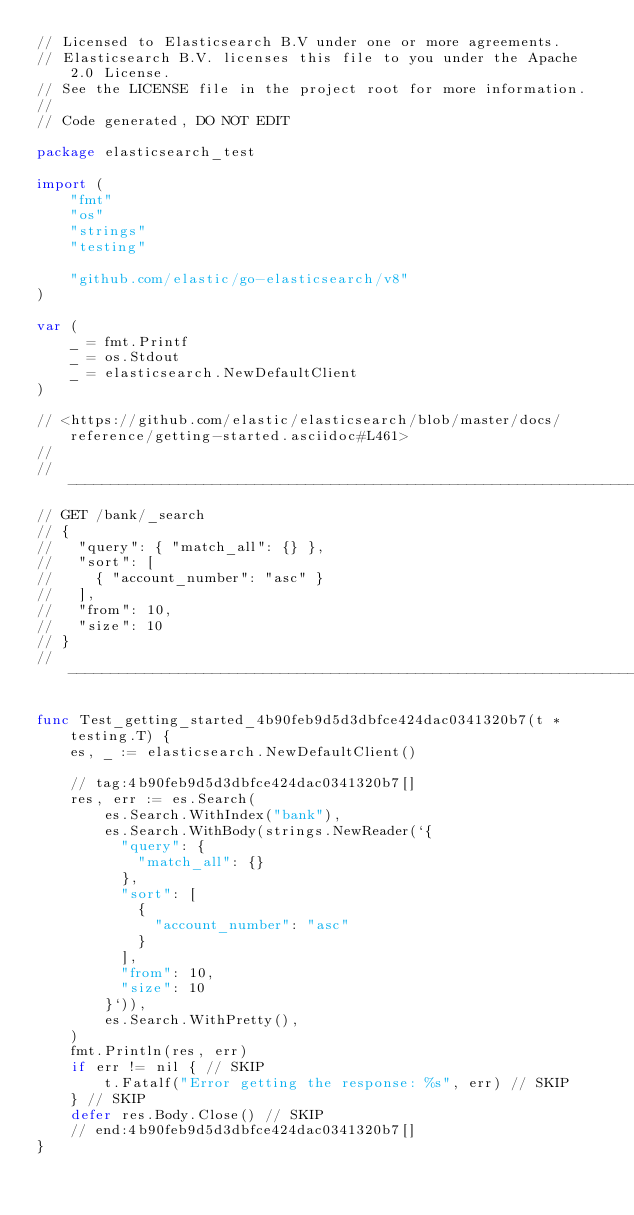<code> <loc_0><loc_0><loc_500><loc_500><_Go_>// Licensed to Elasticsearch B.V under one or more agreements.
// Elasticsearch B.V. licenses this file to you under the Apache 2.0 License.
// See the LICENSE file in the project root for more information.
//
// Code generated, DO NOT EDIT

package elasticsearch_test

import (
	"fmt"
	"os"
	"strings"
	"testing"

	"github.com/elastic/go-elasticsearch/v8"
)

var (
	_ = fmt.Printf
	_ = os.Stdout
	_ = elasticsearch.NewDefaultClient
)

// <https://github.com/elastic/elasticsearch/blob/master/docs/reference/getting-started.asciidoc#L461>
//
// --------------------------------------------------------------------------------
// GET /bank/_search
// {
//   "query": { "match_all": {} },
//   "sort": [
//     { "account_number": "asc" }
//   ],
//   "from": 10,
//   "size": 10
// }
// --------------------------------------------------------------------------------

func Test_getting_started_4b90feb9d5d3dbfce424dac0341320b7(t *testing.T) {
	es, _ := elasticsearch.NewDefaultClient()

	// tag:4b90feb9d5d3dbfce424dac0341320b7[]
	res, err := es.Search(
		es.Search.WithIndex("bank"),
		es.Search.WithBody(strings.NewReader(`{
		  "query": {
		    "match_all": {}
		  },
		  "sort": [
		    {
		      "account_number": "asc"
		    }
		  ],
		  "from": 10,
		  "size": 10
		}`)),
		es.Search.WithPretty(),
	)
	fmt.Println(res, err)
	if err != nil { // SKIP
		t.Fatalf("Error getting the response: %s", err) // SKIP
	} // SKIP
	defer res.Body.Close() // SKIP
	// end:4b90feb9d5d3dbfce424dac0341320b7[]
}
</code> 